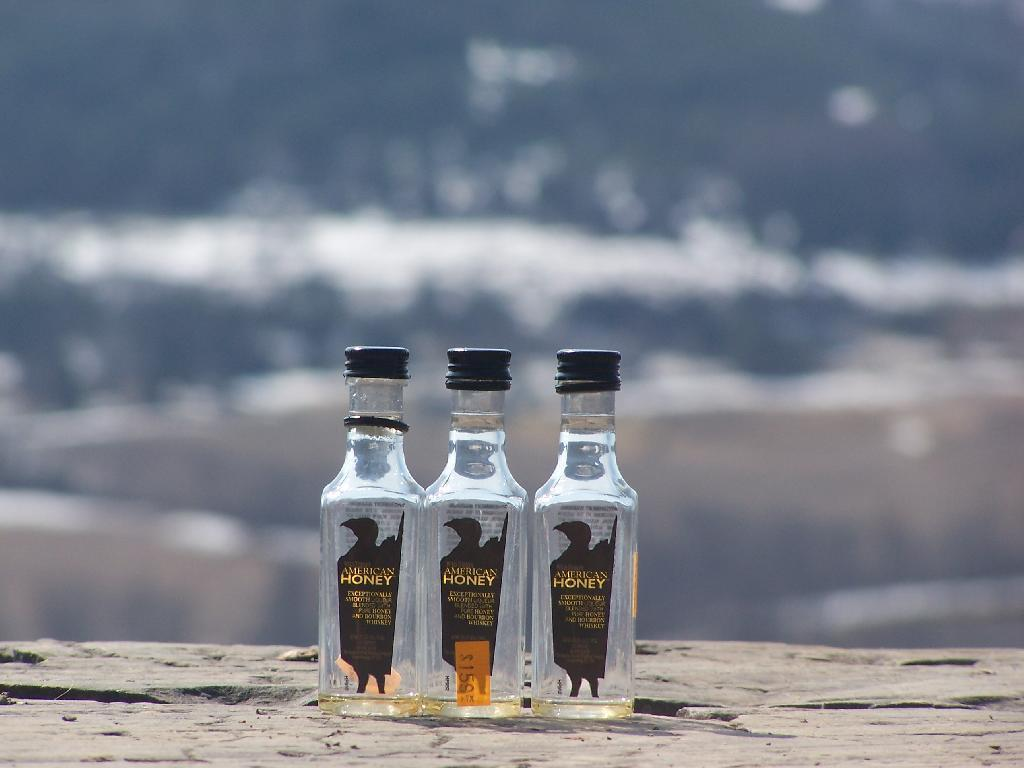<image>
Provide a brief description of the given image. Three bottles of American Honey Whiskey sit on a road 